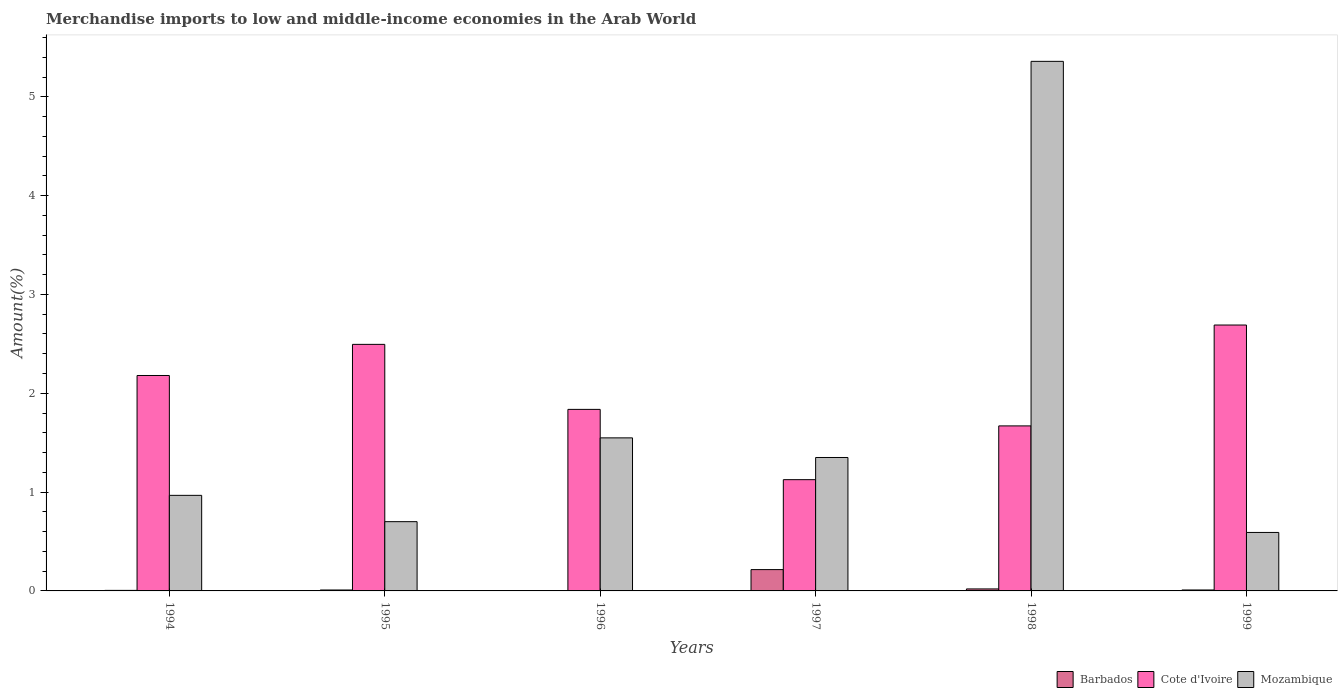Are the number of bars on each tick of the X-axis equal?
Offer a terse response. Yes. How many bars are there on the 6th tick from the right?
Make the answer very short. 3. In how many cases, is the number of bars for a given year not equal to the number of legend labels?
Offer a very short reply. 0. What is the percentage of amount earned from merchandise imports in Cote d'Ivoire in 1999?
Offer a terse response. 2.69. Across all years, what is the maximum percentage of amount earned from merchandise imports in Cote d'Ivoire?
Give a very brief answer. 2.69. Across all years, what is the minimum percentage of amount earned from merchandise imports in Mozambique?
Your answer should be compact. 0.59. In which year was the percentage of amount earned from merchandise imports in Cote d'Ivoire minimum?
Keep it short and to the point. 1997. What is the total percentage of amount earned from merchandise imports in Mozambique in the graph?
Keep it short and to the point. 10.52. What is the difference between the percentage of amount earned from merchandise imports in Cote d'Ivoire in 1995 and that in 1999?
Provide a succinct answer. -0.2. What is the difference between the percentage of amount earned from merchandise imports in Barbados in 1997 and the percentage of amount earned from merchandise imports in Mozambique in 1994?
Provide a short and direct response. -0.75. What is the average percentage of amount earned from merchandise imports in Cote d'Ivoire per year?
Your response must be concise. 2. In the year 1996, what is the difference between the percentage of amount earned from merchandise imports in Mozambique and percentage of amount earned from merchandise imports in Barbados?
Provide a short and direct response. 1.55. What is the ratio of the percentage of amount earned from merchandise imports in Barbados in 1995 to that in 1999?
Keep it short and to the point. 0.98. What is the difference between the highest and the second highest percentage of amount earned from merchandise imports in Mozambique?
Offer a terse response. 3.81. What is the difference between the highest and the lowest percentage of amount earned from merchandise imports in Mozambique?
Your answer should be compact. 4.77. In how many years, is the percentage of amount earned from merchandise imports in Mozambique greater than the average percentage of amount earned from merchandise imports in Mozambique taken over all years?
Keep it short and to the point. 1. What does the 2nd bar from the left in 1996 represents?
Your answer should be compact. Cote d'Ivoire. What does the 1st bar from the right in 1999 represents?
Your response must be concise. Mozambique. How many bars are there?
Make the answer very short. 18. Are all the bars in the graph horizontal?
Your answer should be compact. No. What is the difference between two consecutive major ticks on the Y-axis?
Give a very brief answer. 1. Does the graph contain grids?
Ensure brevity in your answer.  No. How many legend labels are there?
Ensure brevity in your answer.  3. How are the legend labels stacked?
Your answer should be compact. Horizontal. What is the title of the graph?
Provide a succinct answer. Merchandise imports to low and middle-income economies in the Arab World. Does "Malaysia" appear as one of the legend labels in the graph?
Make the answer very short. No. What is the label or title of the Y-axis?
Keep it short and to the point. Amount(%). What is the Amount(%) of Barbados in 1994?
Keep it short and to the point. 0.01. What is the Amount(%) of Cote d'Ivoire in 1994?
Ensure brevity in your answer.  2.18. What is the Amount(%) of Mozambique in 1994?
Offer a very short reply. 0.97. What is the Amount(%) in Barbados in 1995?
Your response must be concise. 0.01. What is the Amount(%) in Cote d'Ivoire in 1995?
Your answer should be compact. 2.49. What is the Amount(%) in Mozambique in 1995?
Ensure brevity in your answer.  0.7. What is the Amount(%) in Barbados in 1996?
Provide a short and direct response. 0. What is the Amount(%) of Cote d'Ivoire in 1996?
Offer a terse response. 1.84. What is the Amount(%) in Mozambique in 1996?
Provide a succinct answer. 1.55. What is the Amount(%) of Barbados in 1997?
Offer a very short reply. 0.22. What is the Amount(%) of Cote d'Ivoire in 1997?
Your answer should be very brief. 1.13. What is the Amount(%) of Mozambique in 1997?
Your answer should be very brief. 1.35. What is the Amount(%) of Barbados in 1998?
Provide a succinct answer. 0.02. What is the Amount(%) in Cote d'Ivoire in 1998?
Give a very brief answer. 1.67. What is the Amount(%) of Mozambique in 1998?
Offer a terse response. 5.36. What is the Amount(%) of Barbados in 1999?
Your response must be concise. 0.01. What is the Amount(%) of Cote d'Ivoire in 1999?
Your answer should be compact. 2.69. What is the Amount(%) of Mozambique in 1999?
Offer a terse response. 0.59. Across all years, what is the maximum Amount(%) of Barbados?
Your answer should be compact. 0.22. Across all years, what is the maximum Amount(%) of Cote d'Ivoire?
Make the answer very short. 2.69. Across all years, what is the maximum Amount(%) of Mozambique?
Your response must be concise. 5.36. Across all years, what is the minimum Amount(%) of Barbados?
Offer a terse response. 0. Across all years, what is the minimum Amount(%) in Cote d'Ivoire?
Offer a very short reply. 1.13. Across all years, what is the minimum Amount(%) in Mozambique?
Your answer should be compact. 0.59. What is the total Amount(%) in Barbados in the graph?
Provide a succinct answer. 0.26. What is the total Amount(%) in Cote d'Ivoire in the graph?
Offer a terse response. 12. What is the total Amount(%) in Mozambique in the graph?
Offer a very short reply. 10.52. What is the difference between the Amount(%) in Barbados in 1994 and that in 1995?
Ensure brevity in your answer.  -0. What is the difference between the Amount(%) of Cote d'Ivoire in 1994 and that in 1995?
Provide a succinct answer. -0.31. What is the difference between the Amount(%) of Mozambique in 1994 and that in 1995?
Offer a terse response. 0.27. What is the difference between the Amount(%) in Barbados in 1994 and that in 1996?
Your answer should be compact. 0. What is the difference between the Amount(%) in Cote d'Ivoire in 1994 and that in 1996?
Give a very brief answer. 0.34. What is the difference between the Amount(%) in Mozambique in 1994 and that in 1996?
Your answer should be compact. -0.58. What is the difference between the Amount(%) of Barbados in 1994 and that in 1997?
Provide a short and direct response. -0.21. What is the difference between the Amount(%) of Cote d'Ivoire in 1994 and that in 1997?
Your answer should be compact. 1.05. What is the difference between the Amount(%) of Mozambique in 1994 and that in 1997?
Make the answer very short. -0.38. What is the difference between the Amount(%) of Barbados in 1994 and that in 1998?
Keep it short and to the point. -0.01. What is the difference between the Amount(%) in Cote d'Ivoire in 1994 and that in 1998?
Keep it short and to the point. 0.51. What is the difference between the Amount(%) of Mozambique in 1994 and that in 1998?
Provide a short and direct response. -4.39. What is the difference between the Amount(%) in Barbados in 1994 and that in 1999?
Your answer should be compact. -0. What is the difference between the Amount(%) of Cote d'Ivoire in 1994 and that in 1999?
Make the answer very short. -0.51. What is the difference between the Amount(%) of Mozambique in 1994 and that in 1999?
Offer a terse response. 0.38. What is the difference between the Amount(%) of Barbados in 1995 and that in 1996?
Your answer should be compact. 0.01. What is the difference between the Amount(%) in Cote d'Ivoire in 1995 and that in 1996?
Give a very brief answer. 0.66. What is the difference between the Amount(%) of Mozambique in 1995 and that in 1996?
Ensure brevity in your answer.  -0.85. What is the difference between the Amount(%) in Barbados in 1995 and that in 1997?
Make the answer very short. -0.21. What is the difference between the Amount(%) in Cote d'Ivoire in 1995 and that in 1997?
Your response must be concise. 1.37. What is the difference between the Amount(%) in Mozambique in 1995 and that in 1997?
Offer a very short reply. -0.65. What is the difference between the Amount(%) of Barbados in 1995 and that in 1998?
Provide a succinct answer. -0.01. What is the difference between the Amount(%) of Cote d'Ivoire in 1995 and that in 1998?
Provide a short and direct response. 0.83. What is the difference between the Amount(%) in Mozambique in 1995 and that in 1998?
Your answer should be compact. -4.66. What is the difference between the Amount(%) of Barbados in 1995 and that in 1999?
Keep it short and to the point. -0. What is the difference between the Amount(%) of Cote d'Ivoire in 1995 and that in 1999?
Offer a terse response. -0.2. What is the difference between the Amount(%) in Mozambique in 1995 and that in 1999?
Ensure brevity in your answer.  0.11. What is the difference between the Amount(%) in Barbados in 1996 and that in 1997?
Your answer should be very brief. -0.21. What is the difference between the Amount(%) of Cote d'Ivoire in 1996 and that in 1997?
Give a very brief answer. 0.71. What is the difference between the Amount(%) of Mozambique in 1996 and that in 1997?
Provide a succinct answer. 0.2. What is the difference between the Amount(%) in Barbados in 1996 and that in 1998?
Keep it short and to the point. -0.02. What is the difference between the Amount(%) of Cote d'Ivoire in 1996 and that in 1998?
Your answer should be compact. 0.17. What is the difference between the Amount(%) in Mozambique in 1996 and that in 1998?
Make the answer very short. -3.81. What is the difference between the Amount(%) of Barbados in 1996 and that in 1999?
Offer a very short reply. -0.01. What is the difference between the Amount(%) in Cote d'Ivoire in 1996 and that in 1999?
Provide a short and direct response. -0.85. What is the difference between the Amount(%) in Mozambique in 1996 and that in 1999?
Your answer should be compact. 0.96. What is the difference between the Amount(%) in Barbados in 1997 and that in 1998?
Offer a terse response. 0.2. What is the difference between the Amount(%) in Cote d'Ivoire in 1997 and that in 1998?
Give a very brief answer. -0.54. What is the difference between the Amount(%) in Mozambique in 1997 and that in 1998?
Ensure brevity in your answer.  -4.01. What is the difference between the Amount(%) in Barbados in 1997 and that in 1999?
Make the answer very short. 0.21. What is the difference between the Amount(%) of Cote d'Ivoire in 1997 and that in 1999?
Offer a terse response. -1.56. What is the difference between the Amount(%) in Mozambique in 1997 and that in 1999?
Make the answer very short. 0.76. What is the difference between the Amount(%) in Barbados in 1998 and that in 1999?
Offer a very short reply. 0.01. What is the difference between the Amount(%) in Cote d'Ivoire in 1998 and that in 1999?
Keep it short and to the point. -1.02. What is the difference between the Amount(%) of Mozambique in 1998 and that in 1999?
Your answer should be very brief. 4.77. What is the difference between the Amount(%) in Barbados in 1994 and the Amount(%) in Cote d'Ivoire in 1995?
Ensure brevity in your answer.  -2.49. What is the difference between the Amount(%) in Barbados in 1994 and the Amount(%) in Mozambique in 1995?
Make the answer very short. -0.7. What is the difference between the Amount(%) in Cote d'Ivoire in 1994 and the Amount(%) in Mozambique in 1995?
Keep it short and to the point. 1.48. What is the difference between the Amount(%) of Barbados in 1994 and the Amount(%) of Cote d'Ivoire in 1996?
Your response must be concise. -1.83. What is the difference between the Amount(%) in Barbados in 1994 and the Amount(%) in Mozambique in 1996?
Ensure brevity in your answer.  -1.54. What is the difference between the Amount(%) of Cote d'Ivoire in 1994 and the Amount(%) of Mozambique in 1996?
Your response must be concise. 0.63. What is the difference between the Amount(%) of Barbados in 1994 and the Amount(%) of Cote d'Ivoire in 1997?
Your response must be concise. -1.12. What is the difference between the Amount(%) of Barbados in 1994 and the Amount(%) of Mozambique in 1997?
Provide a short and direct response. -1.34. What is the difference between the Amount(%) in Cote d'Ivoire in 1994 and the Amount(%) in Mozambique in 1997?
Offer a terse response. 0.83. What is the difference between the Amount(%) in Barbados in 1994 and the Amount(%) in Cote d'Ivoire in 1998?
Provide a succinct answer. -1.66. What is the difference between the Amount(%) of Barbados in 1994 and the Amount(%) of Mozambique in 1998?
Your response must be concise. -5.35. What is the difference between the Amount(%) of Cote d'Ivoire in 1994 and the Amount(%) of Mozambique in 1998?
Your response must be concise. -3.18. What is the difference between the Amount(%) of Barbados in 1994 and the Amount(%) of Cote d'Ivoire in 1999?
Give a very brief answer. -2.69. What is the difference between the Amount(%) of Barbados in 1994 and the Amount(%) of Mozambique in 1999?
Provide a succinct answer. -0.59. What is the difference between the Amount(%) of Cote d'Ivoire in 1994 and the Amount(%) of Mozambique in 1999?
Offer a very short reply. 1.59. What is the difference between the Amount(%) in Barbados in 1995 and the Amount(%) in Cote d'Ivoire in 1996?
Offer a terse response. -1.83. What is the difference between the Amount(%) of Barbados in 1995 and the Amount(%) of Mozambique in 1996?
Offer a terse response. -1.54. What is the difference between the Amount(%) in Cote d'Ivoire in 1995 and the Amount(%) in Mozambique in 1996?
Your response must be concise. 0.95. What is the difference between the Amount(%) of Barbados in 1995 and the Amount(%) of Cote d'Ivoire in 1997?
Give a very brief answer. -1.12. What is the difference between the Amount(%) of Barbados in 1995 and the Amount(%) of Mozambique in 1997?
Give a very brief answer. -1.34. What is the difference between the Amount(%) of Cote d'Ivoire in 1995 and the Amount(%) of Mozambique in 1997?
Your answer should be very brief. 1.14. What is the difference between the Amount(%) of Barbados in 1995 and the Amount(%) of Cote d'Ivoire in 1998?
Give a very brief answer. -1.66. What is the difference between the Amount(%) in Barbados in 1995 and the Amount(%) in Mozambique in 1998?
Keep it short and to the point. -5.35. What is the difference between the Amount(%) in Cote d'Ivoire in 1995 and the Amount(%) in Mozambique in 1998?
Your answer should be very brief. -2.86. What is the difference between the Amount(%) of Barbados in 1995 and the Amount(%) of Cote d'Ivoire in 1999?
Ensure brevity in your answer.  -2.68. What is the difference between the Amount(%) of Barbados in 1995 and the Amount(%) of Mozambique in 1999?
Offer a very short reply. -0.58. What is the difference between the Amount(%) in Cote d'Ivoire in 1995 and the Amount(%) in Mozambique in 1999?
Your response must be concise. 1.9. What is the difference between the Amount(%) of Barbados in 1996 and the Amount(%) of Cote d'Ivoire in 1997?
Offer a terse response. -1.12. What is the difference between the Amount(%) of Barbados in 1996 and the Amount(%) of Mozambique in 1997?
Your answer should be compact. -1.35. What is the difference between the Amount(%) of Cote d'Ivoire in 1996 and the Amount(%) of Mozambique in 1997?
Give a very brief answer. 0.49. What is the difference between the Amount(%) in Barbados in 1996 and the Amount(%) in Cote d'Ivoire in 1998?
Provide a short and direct response. -1.67. What is the difference between the Amount(%) in Barbados in 1996 and the Amount(%) in Mozambique in 1998?
Give a very brief answer. -5.36. What is the difference between the Amount(%) of Cote d'Ivoire in 1996 and the Amount(%) of Mozambique in 1998?
Your answer should be compact. -3.52. What is the difference between the Amount(%) in Barbados in 1996 and the Amount(%) in Cote d'Ivoire in 1999?
Your answer should be compact. -2.69. What is the difference between the Amount(%) in Barbados in 1996 and the Amount(%) in Mozambique in 1999?
Offer a terse response. -0.59. What is the difference between the Amount(%) in Cote d'Ivoire in 1996 and the Amount(%) in Mozambique in 1999?
Provide a short and direct response. 1.25. What is the difference between the Amount(%) of Barbados in 1997 and the Amount(%) of Cote d'Ivoire in 1998?
Give a very brief answer. -1.45. What is the difference between the Amount(%) in Barbados in 1997 and the Amount(%) in Mozambique in 1998?
Provide a short and direct response. -5.14. What is the difference between the Amount(%) of Cote d'Ivoire in 1997 and the Amount(%) of Mozambique in 1998?
Keep it short and to the point. -4.23. What is the difference between the Amount(%) of Barbados in 1997 and the Amount(%) of Cote d'Ivoire in 1999?
Your response must be concise. -2.47. What is the difference between the Amount(%) of Barbados in 1997 and the Amount(%) of Mozambique in 1999?
Provide a short and direct response. -0.38. What is the difference between the Amount(%) of Cote d'Ivoire in 1997 and the Amount(%) of Mozambique in 1999?
Ensure brevity in your answer.  0.53. What is the difference between the Amount(%) in Barbados in 1998 and the Amount(%) in Cote d'Ivoire in 1999?
Give a very brief answer. -2.67. What is the difference between the Amount(%) of Barbados in 1998 and the Amount(%) of Mozambique in 1999?
Offer a terse response. -0.57. What is the difference between the Amount(%) of Cote d'Ivoire in 1998 and the Amount(%) of Mozambique in 1999?
Provide a short and direct response. 1.08. What is the average Amount(%) in Barbados per year?
Ensure brevity in your answer.  0.04. What is the average Amount(%) of Cote d'Ivoire per year?
Your answer should be compact. 2. What is the average Amount(%) of Mozambique per year?
Keep it short and to the point. 1.75. In the year 1994, what is the difference between the Amount(%) in Barbados and Amount(%) in Cote d'Ivoire?
Make the answer very short. -2.17. In the year 1994, what is the difference between the Amount(%) in Barbados and Amount(%) in Mozambique?
Provide a succinct answer. -0.96. In the year 1994, what is the difference between the Amount(%) of Cote d'Ivoire and Amount(%) of Mozambique?
Make the answer very short. 1.21. In the year 1995, what is the difference between the Amount(%) of Barbados and Amount(%) of Cote d'Ivoire?
Your answer should be very brief. -2.49. In the year 1995, what is the difference between the Amount(%) in Barbados and Amount(%) in Mozambique?
Keep it short and to the point. -0.69. In the year 1995, what is the difference between the Amount(%) of Cote d'Ivoire and Amount(%) of Mozambique?
Offer a very short reply. 1.79. In the year 1996, what is the difference between the Amount(%) in Barbados and Amount(%) in Cote d'Ivoire?
Offer a very short reply. -1.83. In the year 1996, what is the difference between the Amount(%) in Barbados and Amount(%) in Mozambique?
Offer a terse response. -1.55. In the year 1996, what is the difference between the Amount(%) in Cote d'Ivoire and Amount(%) in Mozambique?
Your answer should be very brief. 0.29. In the year 1997, what is the difference between the Amount(%) of Barbados and Amount(%) of Cote d'Ivoire?
Make the answer very short. -0.91. In the year 1997, what is the difference between the Amount(%) in Barbados and Amount(%) in Mozambique?
Provide a succinct answer. -1.13. In the year 1997, what is the difference between the Amount(%) in Cote d'Ivoire and Amount(%) in Mozambique?
Keep it short and to the point. -0.22. In the year 1998, what is the difference between the Amount(%) of Barbados and Amount(%) of Cote d'Ivoire?
Provide a short and direct response. -1.65. In the year 1998, what is the difference between the Amount(%) of Barbados and Amount(%) of Mozambique?
Provide a succinct answer. -5.34. In the year 1998, what is the difference between the Amount(%) of Cote d'Ivoire and Amount(%) of Mozambique?
Your response must be concise. -3.69. In the year 1999, what is the difference between the Amount(%) of Barbados and Amount(%) of Cote d'Ivoire?
Your answer should be compact. -2.68. In the year 1999, what is the difference between the Amount(%) in Barbados and Amount(%) in Mozambique?
Keep it short and to the point. -0.58. In the year 1999, what is the difference between the Amount(%) in Cote d'Ivoire and Amount(%) in Mozambique?
Your answer should be very brief. 2.1. What is the ratio of the Amount(%) of Barbados in 1994 to that in 1995?
Provide a short and direct response. 0.57. What is the ratio of the Amount(%) in Cote d'Ivoire in 1994 to that in 1995?
Your answer should be compact. 0.87. What is the ratio of the Amount(%) in Mozambique in 1994 to that in 1995?
Provide a short and direct response. 1.38. What is the ratio of the Amount(%) of Barbados in 1994 to that in 1996?
Offer a very short reply. 1.94. What is the ratio of the Amount(%) in Cote d'Ivoire in 1994 to that in 1996?
Offer a very short reply. 1.19. What is the ratio of the Amount(%) of Mozambique in 1994 to that in 1996?
Keep it short and to the point. 0.62. What is the ratio of the Amount(%) of Barbados in 1994 to that in 1997?
Your response must be concise. 0.02. What is the ratio of the Amount(%) of Cote d'Ivoire in 1994 to that in 1997?
Give a very brief answer. 1.94. What is the ratio of the Amount(%) of Mozambique in 1994 to that in 1997?
Offer a very short reply. 0.72. What is the ratio of the Amount(%) of Barbados in 1994 to that in 1998?
Make the answer very short. 0.27. What is the ratio of the Amount(%) of Cote d'Ivoire in 1994 to that in 1998?
Ensure brevity in your answer.  1.31. What is the ratio of the Amount(%) in Mozambique in 1994 to that in 1998?
Your answer should be compact. 0.18. What is the ratio of the Amount(%) in Barbados in 1994 to that in 1999?
Keep it short and to the point. 0.56. What is the ratio of the Amount(%) of Cote d'Ivoire in 1994 to that in 1999?
Give a very brief answer. 0.81. What is the ratio of the Amount(%) in Mozambique in 1994 to that in 1999?
Make the answer very short. 1.63. What is the ratio of the Amount(%) of Barbados in 1995 to that in 1996?
Give a very brief answer. 3.37. What is the ratio of the Amount(%) of Cote d'Ivoire in 1995 to that in 1996?
Make the answer very short. 1.36. What is the ratio of the Amount(%) in Mozambique in 1995 to that in 1996?
Offer a terse response. 0.45. What is the ratio of the Amount(%) of Barbados in 1995 to that in 1997?
Provide a short and direct response. 0.04. What is the ratio of the Amount(%) of Cote d'Ivoire in 1995 to that in 1997?
Your answer should be compact. 2.22. What is the ratio of the Amount(%) of Mozambique in 1995 to that in 1997?
Provide a short and direct response. 0.52. What is the ratio of the Amount(%) in Barbados in 1995 to that in 1998?
Ensure brevity in your answer.  0.46. What is the ratio of the Amount(%) of Cote d'Ivoire in 1995 to that in 1998?
Your answer should be compact. 1.49. What is the ratio of the Amount(%) in Mozambique in 1995 to that in 1998?
Offer a terse response. 0.13. What is the ratio of the Amount(%) of Barbados in 1995 to that in 1999?
Your answer should be very brief. 0.98. What is the ratio of the Amount(%) of Cote d'Ivoire in 1995 to that in 1999?
Your response must be concise. 0.93. What is the ratio of the Amount(%) of Mozambique in 1995 to that in 1999?
Give a very brief answer. 1.18. What is the ratio of the Amount(%) of Barbados in 1996 to that in 1997?
Your answer should be compact. 0.01. What is the ratio of the Amount(%) in Cote d'Ivoire in 1996 to that in 1997?
Provide a short and direct response. 1.63. What is the ratio of the Amount(%) in Mozambique in 1996 to that in 1997?
Offer a terse response. 1.15. What is the ratio of the Amount(%) in Barbados in 1996 to that in 1998?
Keep it short and to the point. 0.14. What is the ratio of the Amount(%) of Cote d'Ivoire in 1996 to that in 1998?
Your answer should be compact. 1.1. What is the ratio of the Amount(%) of Mozambique in 1996 to that in 1998?
Make the answer very short. 0.29. What is the ratio of the Amount(%) in Barbados in 1996 to that in 1999?
Keep it short and to the point. 0.29. What is the ratio of the Amount(%) of Cote d'Ivoire in 1996 to that in 1999?
Provide a succinct answer. 0.68. What is the ratio of the Amount(%) in Mozambique in 1996 to that in 1999?
Your answer should be very brief. 2.62. What is the ratio of the Amount(%) in Barbados in 1997 to that in 1998?
Ensure brevity in your answer.  10.71. What is the ratio of the Amount(%) of Cote d'Ivoire in 1997 to that in 1998?
Make the answer very short. 0.67. What is the ratio of the Amount(%) of Mozambique in 1997 to that in 1998?
Provide a short and direct response. 0.25. What is the ratio of the Amount(%) of Barbados in 1997 to that in 1999?
Offer a very short reply. 22.62. What is the ratio of the Amount(%) of Cote d'Ivoire in 1997 to that in 1999?
Offer a very short reply. 0.42. What is the ratio of the Amount(%) in Mozambique in 1997 to that in 1999?
Your response must be concise. 2.28. What is the ratio of the Amount(%) in Barbados in 1998 to that in 1999?
Keep it short and to the point. 2.11. What is the ratio of the Amount(%) of Cote d'Ivoire in 1998 to that in 1999?
Keep it short and to the point. 0.62. What is the ratio of the Amount(%) in Mozambique in 1998 to that in 1999?
Keep it short and to the point. 9.06. What is the difference between the highest and the second highest Amount(%) of Barbados?
Offer a very short reply. 0.2. What is the difference between the highest and the second highest Amount(%) in Cote d'Ivoire?
Your answer should be compact. 0.2. What is the difference between the highest and the second highest Amount(%) in Mozambique?
Offer a very short reply. 3.81. What is the difference between the highest and the lowest Amount(%) in Barbados?
Offer a terse response. 0.21. What is the difference between the highest and the lowest Amount(%) in Cote d'Ivoire?
Your answer should be very brief. 1.56. What is the difference between the highest and the lowest Amount(%) in Mozambique?
Give a very brief answer. 4.77. 